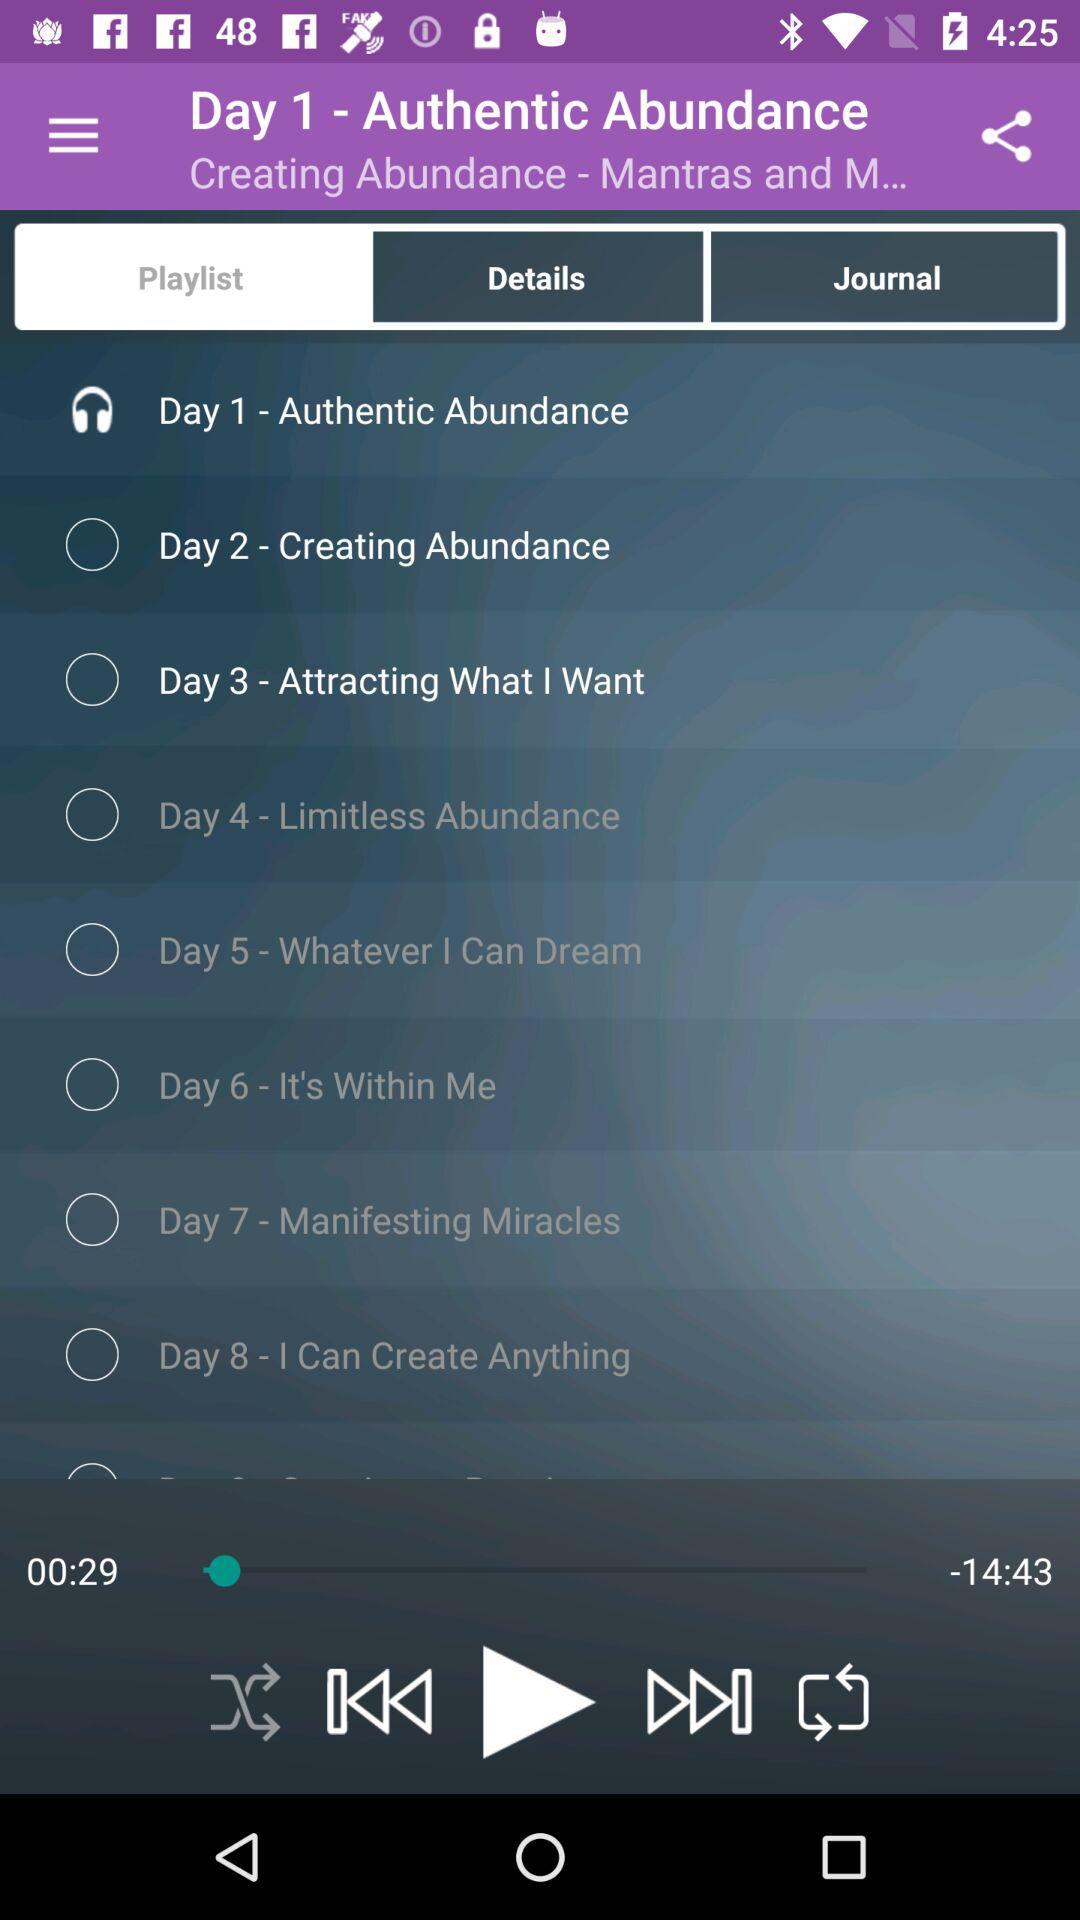What track will be played on day six? The track that will be played on day six is "It's Within Me". 